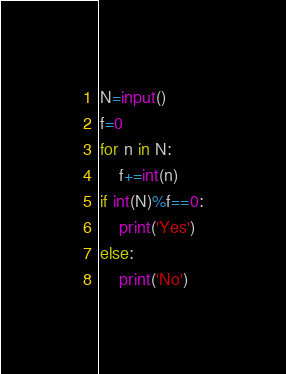Convert code to text. <code><loc_0><loc_0><loc_500><loc_500><_Python_>N=input()
f=0
for n in N:
    f+=int(n)
if int(N)%f==0:
    print('Yes')
else:
    print('No')</code> 